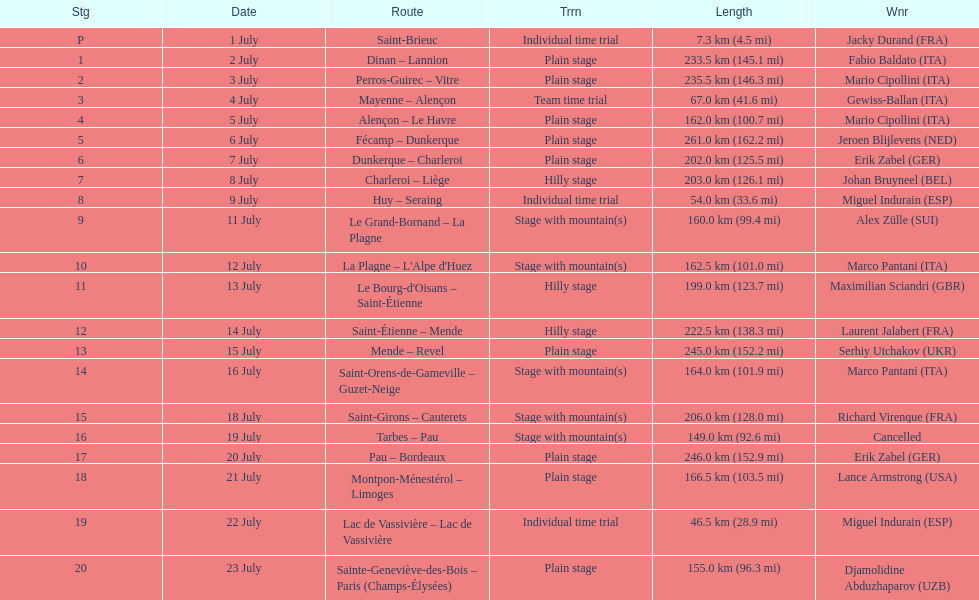Which routes were at least 100 km? Dinan - Lannion, Perros-Guirec - Vitre, Alençon - Le Havre, Fécamp - Dunkerque, Dunkerque - Charleroi, Charleroi - Liège, Le Grand-Bornand - La Plagne, La Plagne - L'Alpe d'Huez, Le Bourg-d'Oisans - Saint-Étienne, Saint-Étienne - Mende, Mende - Revel, Saint-Orens-de-Gameville - Guzet-Neige, Saint-Girons - Cauterets, Tarbes - Pau, Pau - Bordeaux, Montpon-Ménestérol - Limoges, Sainte-Geneviève-des-Bois - Paris (Champs-Élysées). 